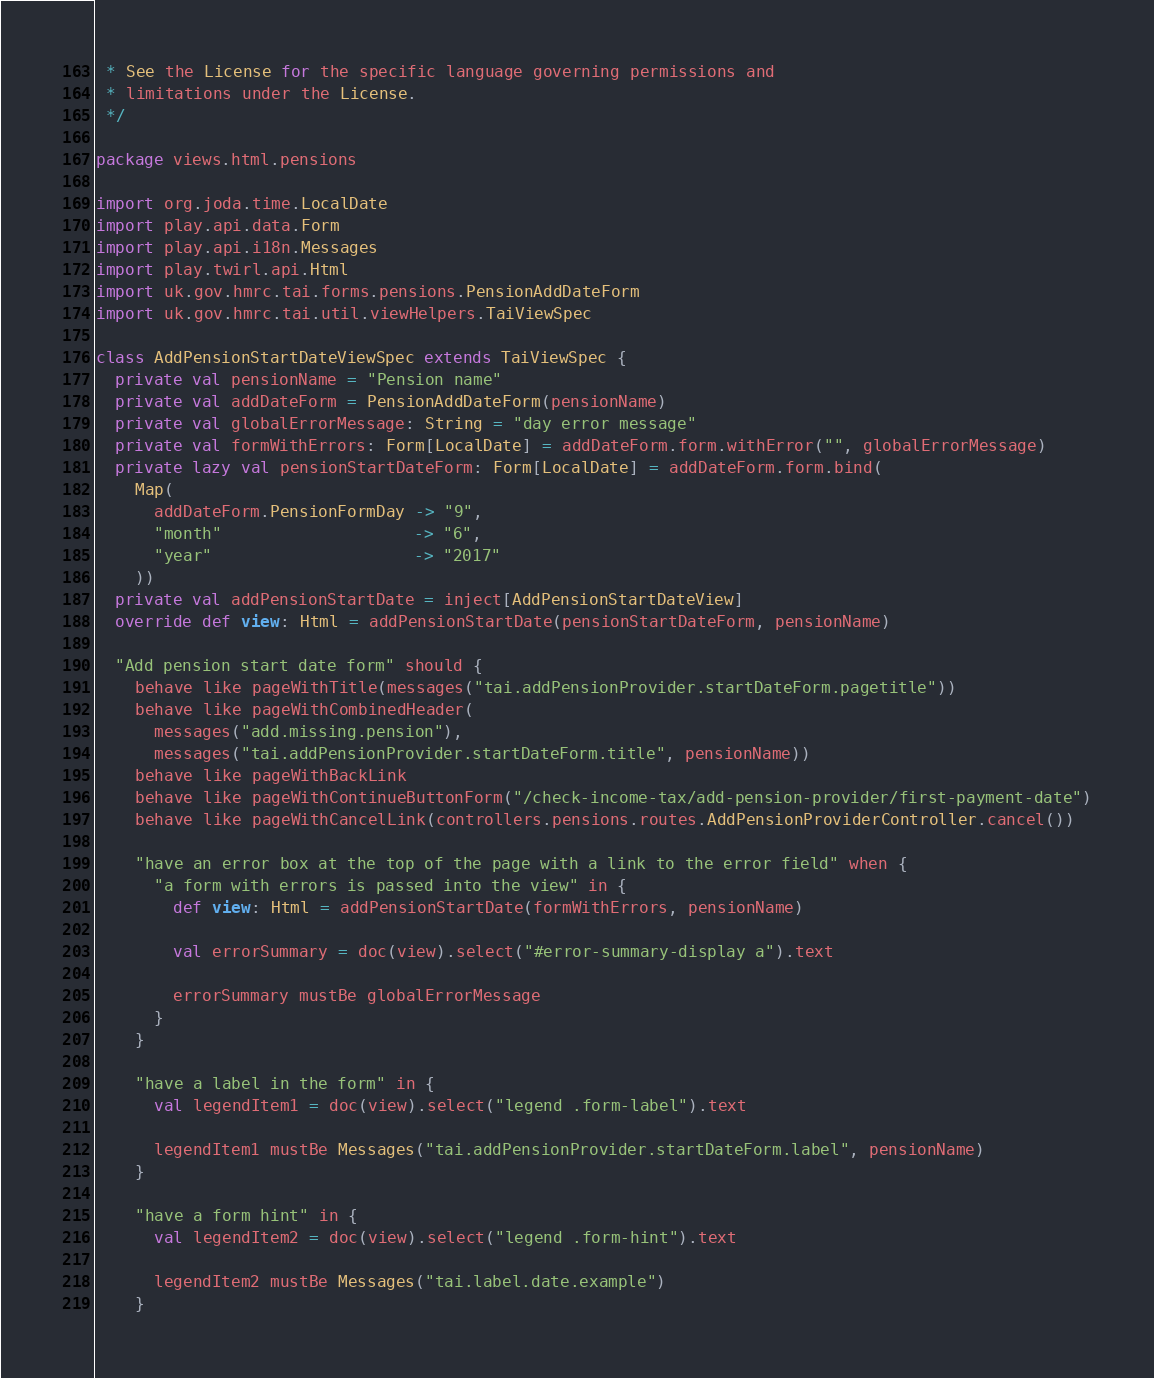Convert code to text. <code><loc_0><loc_0><loc_500><loc_500><_Scala_> * See the License for the specific language governing permissions and
 * limitations under the License.
 */

package views.html.pensions

import org.joda.time.LocalDate
import play.api.data.Form
import play.api.i18n.Messages
import play.twirl.api.Html
import uk.gov.hmrc.tai.forms.pensions.PensionAddDateForm
import uk.gov.hmrc.tai.util.viewHelpers.TaiViewSpec

class AddPensionStartDateViewSpec extends TaiViewSpec {
  private val pensionName = "Pension name"
  private val addDateForm = PensionAddDateForm(pensionName)
  private val globalErrorMessage: String = "day error message"
  private val formWithErrors: Form[LocalDate] = addDateForm.form.withError("", globalErrorMessage)
  private lazy val pensionStartDateForm: Form[LocalDate] = addDateForm.form.bind(
    Map(
      addDateForm.PensionFormDay -> "9",
      "month"                    -> "6",
      "year"                     -> "2017"
    ))
  private val addPensionStartDate = inject[AddPensionStartDateView]
  override def view: Html = addPensionStartDate(pensionStartDateForm, pensionName)

  "Add pension start date form" should {
    behave like pageWithTitle(messages("tai.addPensionProvider.startDateForm.pagetitle"))
    behave like pageWithCombinedHeader(
      messages("add.missing.pension"),
      messages("tai.addPensionProvider.startDateForm.title", pensionName))
    behave like pageWithBackLink
    behave like pageWithContinueButtonForm("/check-income-tax/add-pension-provider/first-payment-date")
    behave like pageWithCancelLink(controllers.pensions.routes.AddPensionProviderController.cancel())

    "have an error box at the top of the page with a link to the error field" when {
      "a form with errors is passed into the view" in {
        def view: Html = addPensionStartDate(formWithErrors, pensionName)

        val errorSummary = doc(view).select("#error-summary-display a").text

        errorSummary mustBe globalErrorMessage
      }
    }

    "have a label in the form" in {
      val legendItem1 = doc(view).select("legend .form-label").text

      legendItem1 mustBe Messages("tai.addPensionProvider.startDateForm.label", pensionName)
    }

    "have a form hint" in {
      val legendItem2 = doc(view).select("legend .form-hint").text

      legendItem2 mustBe Messages("tai.label.date.example")
    }
</code> 